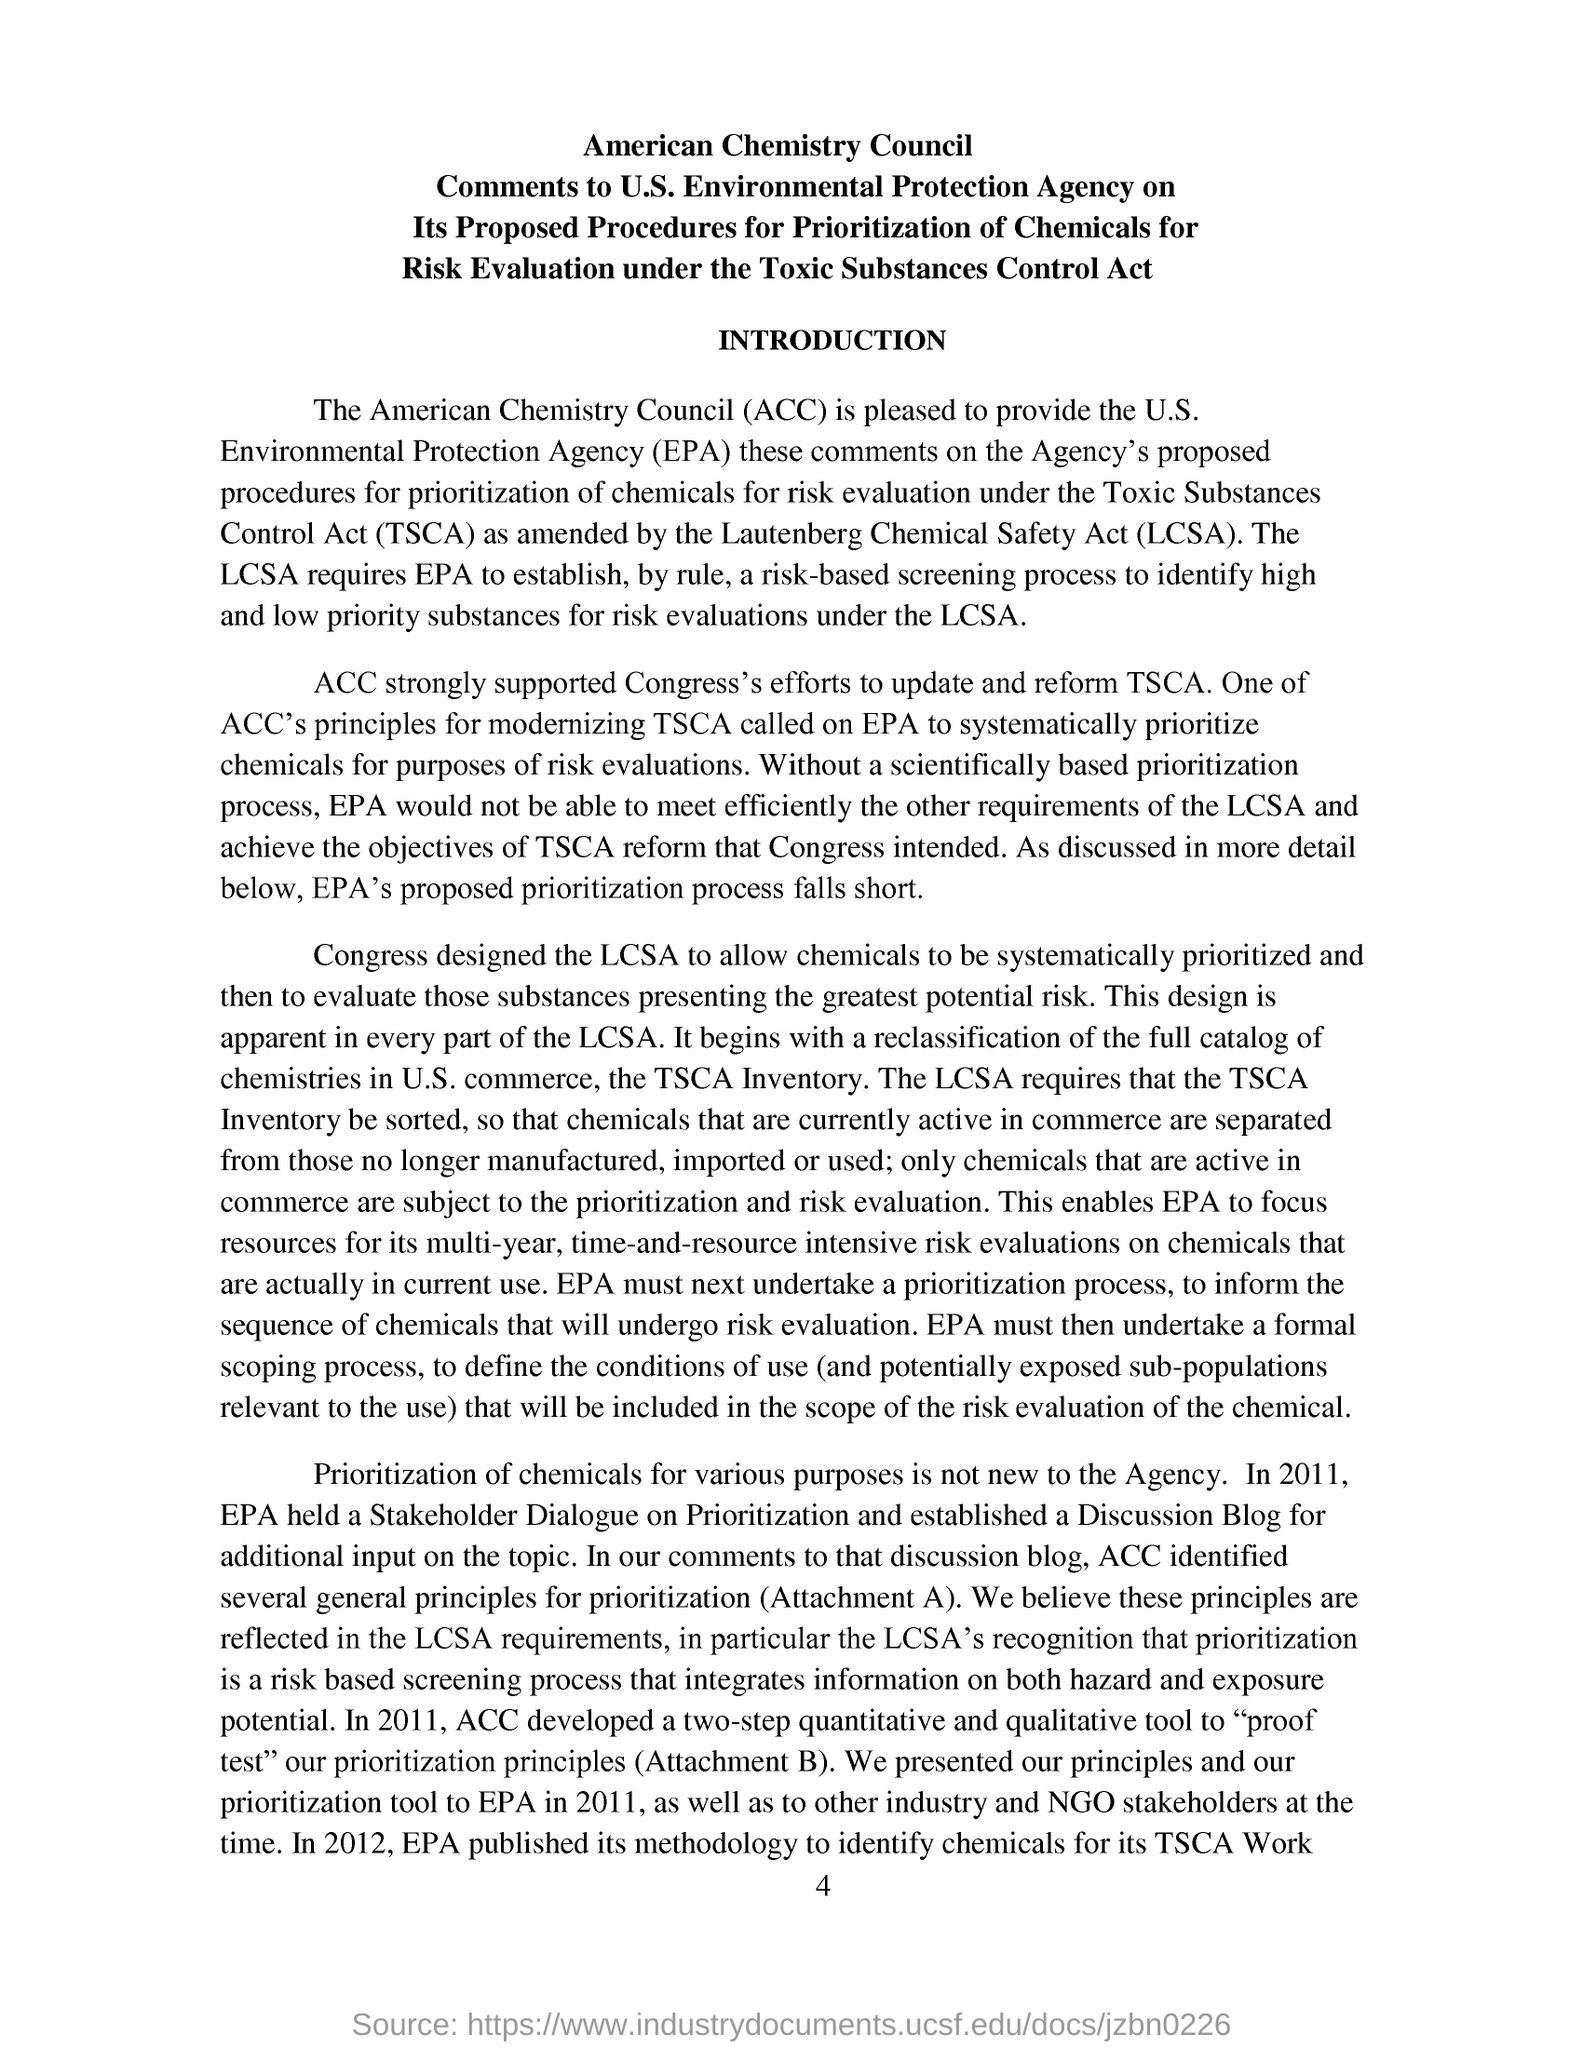Draw attention to some important aspects in this diagram. The Toxic Substances Control Act (TSCA) is an abbreviation. ACC strongly supported Congress's efforts to update and reform the Toxic Substances Control Act (TSCA) to ensure the safe use of chemicals in commerce. We developed a two-step quantitative and qualitative tool to serve as a proof test of our prioritization principles. In 2011, the United States Environmental Protection Agency (EPA) held a Stakeholder Dialogue on the prioritization of chemicals for risk evaluation under the Toxic Substances Control Act (TSCA). The full form of ACC is the American Chemistry Council, an organization that represents the interests of the chemical industry in the United States. 